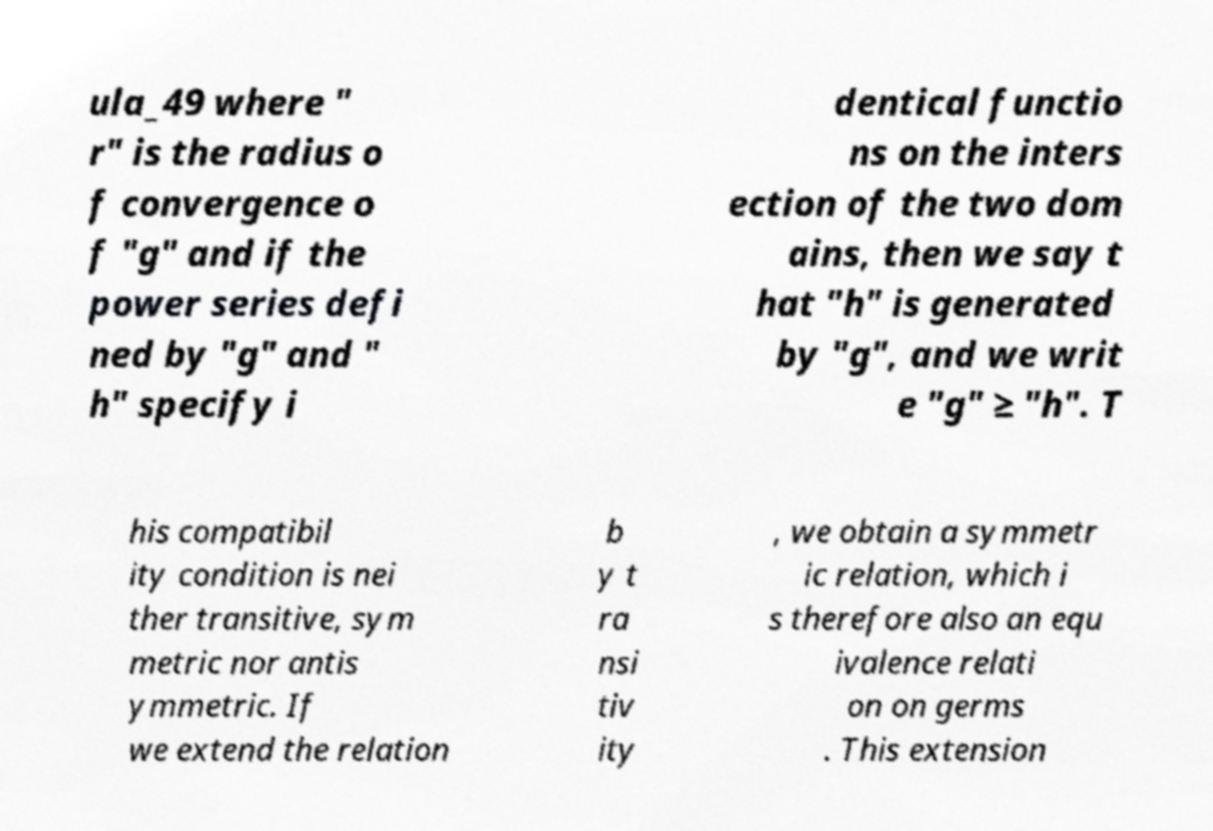Please identify and transcribe the text found in this image. ula_49 where " r" is the radius o f convergence o f "g" and if the power series defi ned by "g" and " h" specify i dentical functio ns on the inters ection of the two dom ains, then we say t hat "h" is generated by "g", and we writ e "g" ≥ "h". T his compatibil ity condition is nei ther transitive, sym metric nor antis ymmetric. If we extend the relation b y t ra nsi tiv ity , we obtain a symmetr ic relation, which i s therefore also an equ ivalence relati on on germs . This extension 